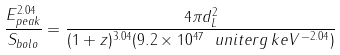Convert formula to latex. <formula><loc_0><loc_0><loc_500><loc_500>\frac { E ^ { 2 . 0 4 } _ { p e a k } } { S _ { b o l o } } = \frac { 4 \pi d _ { L } ^ { 2 } } { ( 1 + z ) ^ { 3 . 0 4 } ( 9 . 2 \times 1 0 ^ { 4 7 } \ u n i t { e r g \, k e V ^ { - 2 . 0 4 } } ) }</formula> 